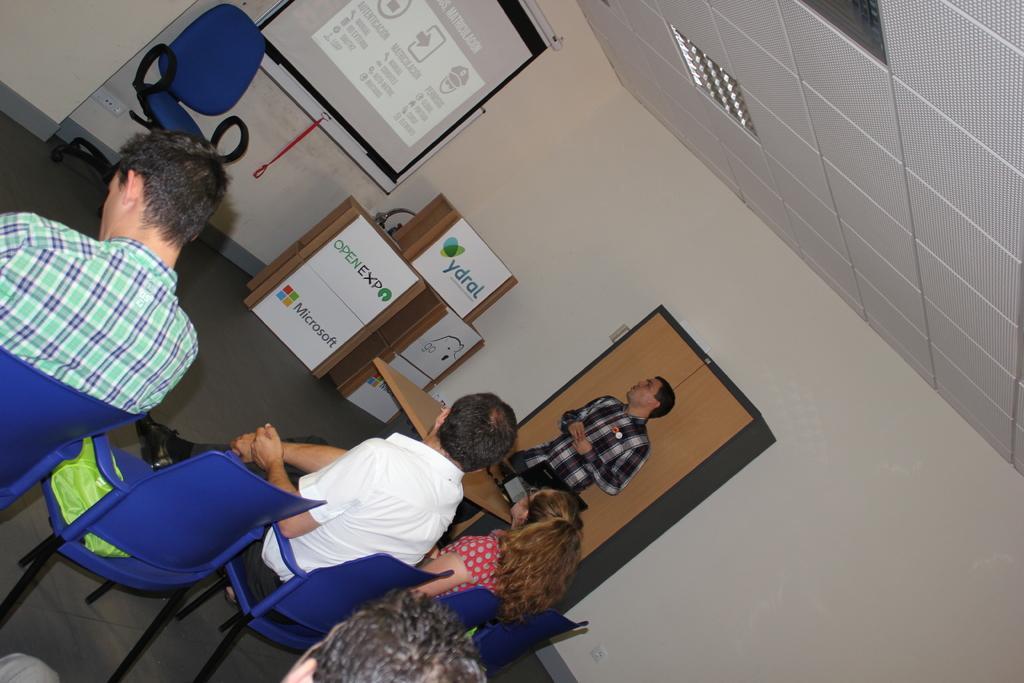In one or two sentences, can you explain what this image depicts? In this image, there are three persons wearing clothes and sitting on chairs. There is a screen and chair at the top of the image. There is a person in the middle of the image wearing clothes and standing in front of the table. There is a ceiling in the top right of the image. 